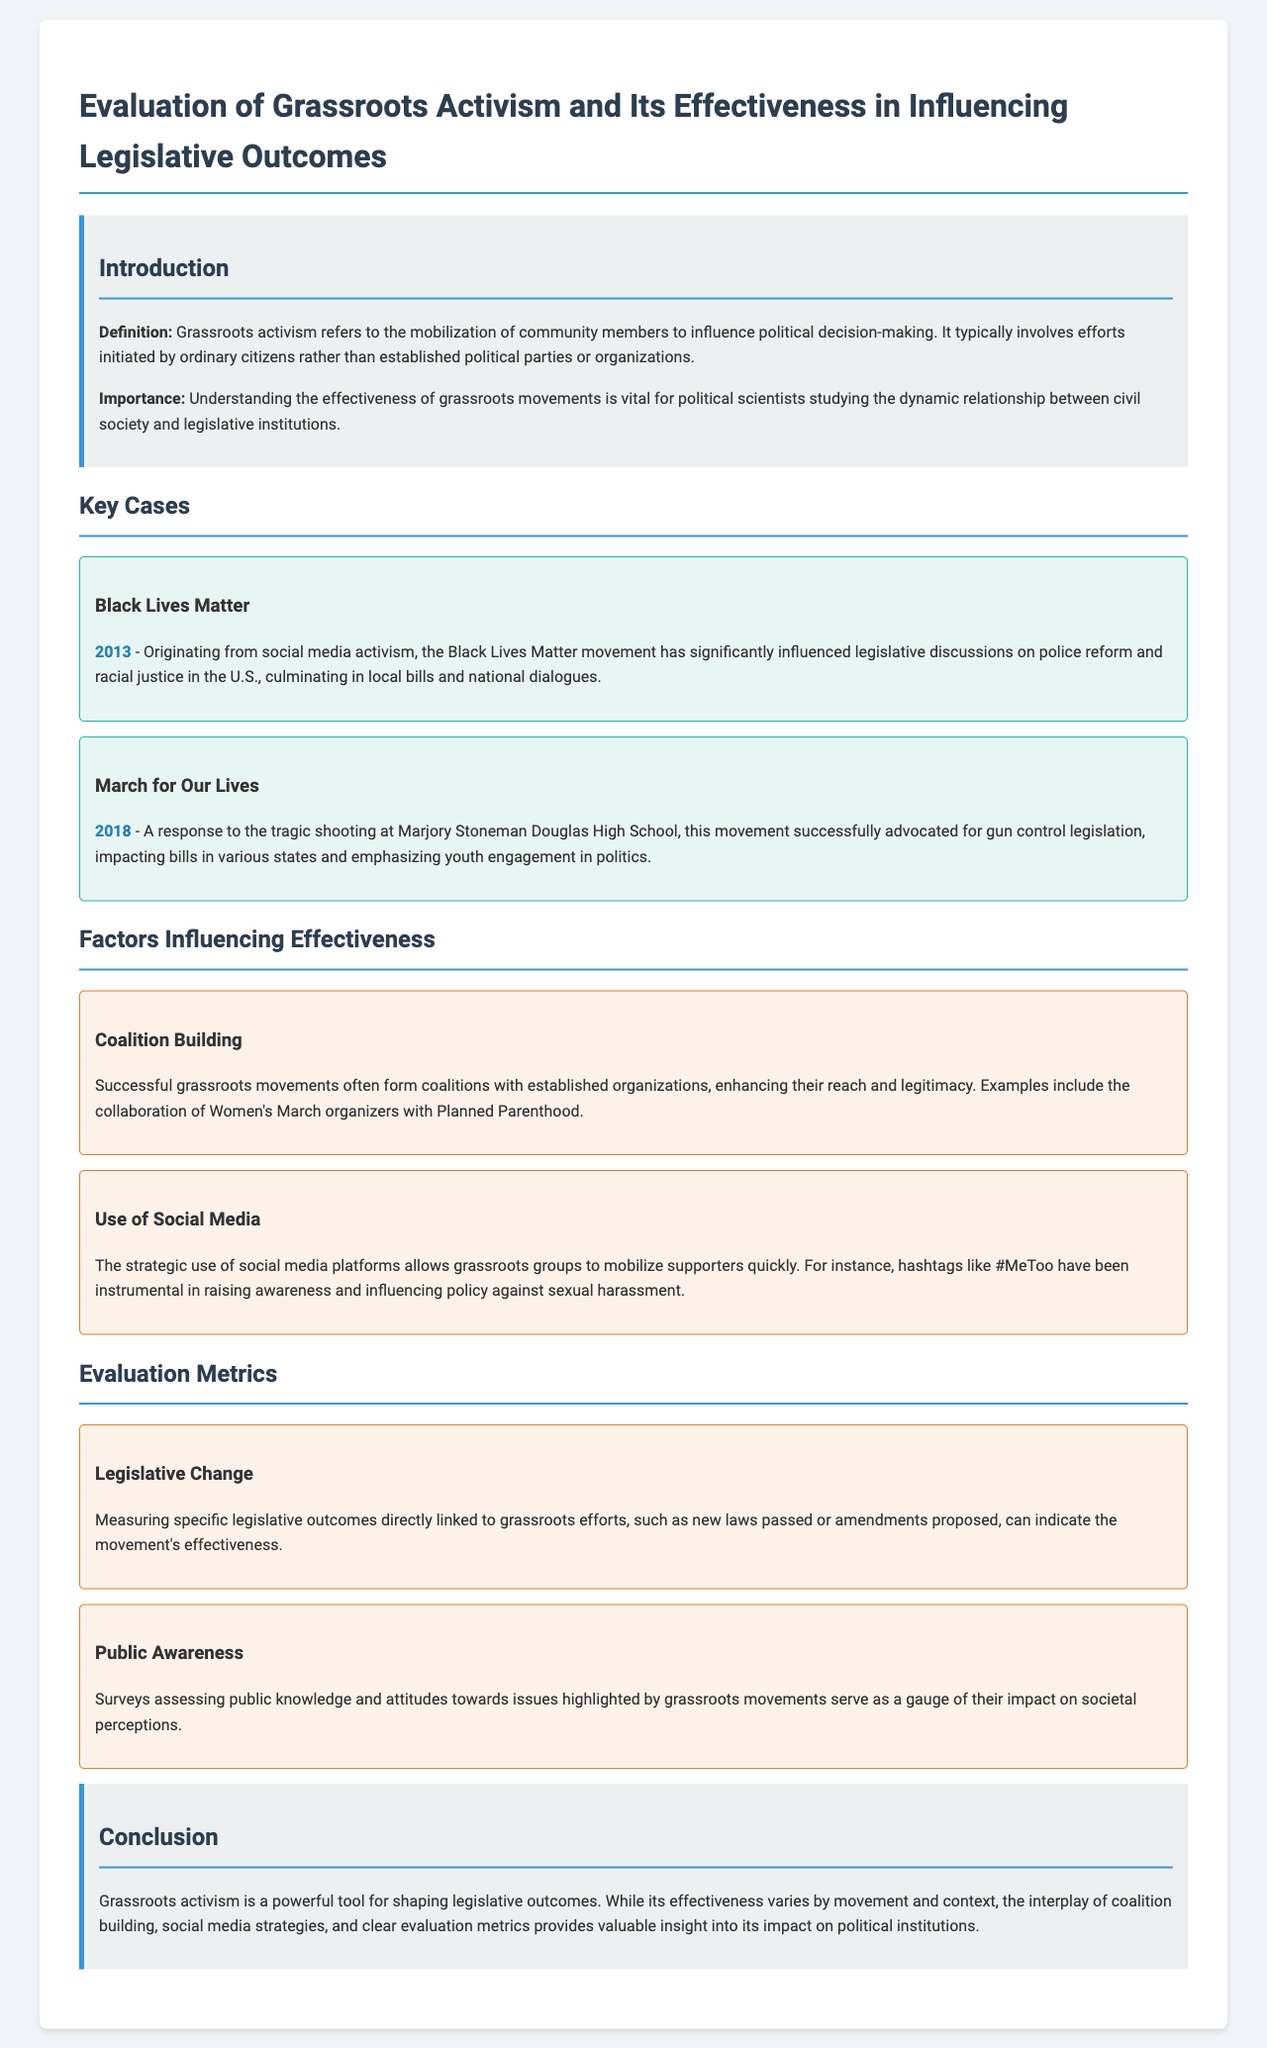What year did the Black Lives Matter movement originate? The document states that the Black Lives Matter movement originated in 2013.
Answer: 2013 What key factor enhances the reach of grassroots movements? The document mentions coalition building with established organizations as a key factor enhancing reach.
Answer: Coalition Building Which movement advocated for gun control legislation? The March for Our Lives movement is highlighted in the document as advocating for gun control legislation.
Answer: March for Our Lives What evaluation metric measures public attitudes towards issues? The document describes surveys assessing public knowledge and attitudes as a metric for evaluating grassroots impact.
Answer: Public Awareness What is a significant social media hashtag mentioned in the report? The document refers to the hashtag #MeToo as significant in raising awareness and influencing policy.
Answer: #MeToo What two key factors influence the effectiveness of grassroots activism? The document specifies coalition building and use of social media as two key factors influencing effectiveness.
Answer: Coalition Building, Use of Social Media Which tragic event triggered the March for Our Lives movement? The document notes that the movement was a response to the shooting at Marjory Stoneman Douglas High School.
Answer: Marjory Stoneman Douglas High School How does the document categorize the introduction section? The introduction section is categorized under "Introduction" in the document, which provides definitions and importance.
Answer: Introduction 